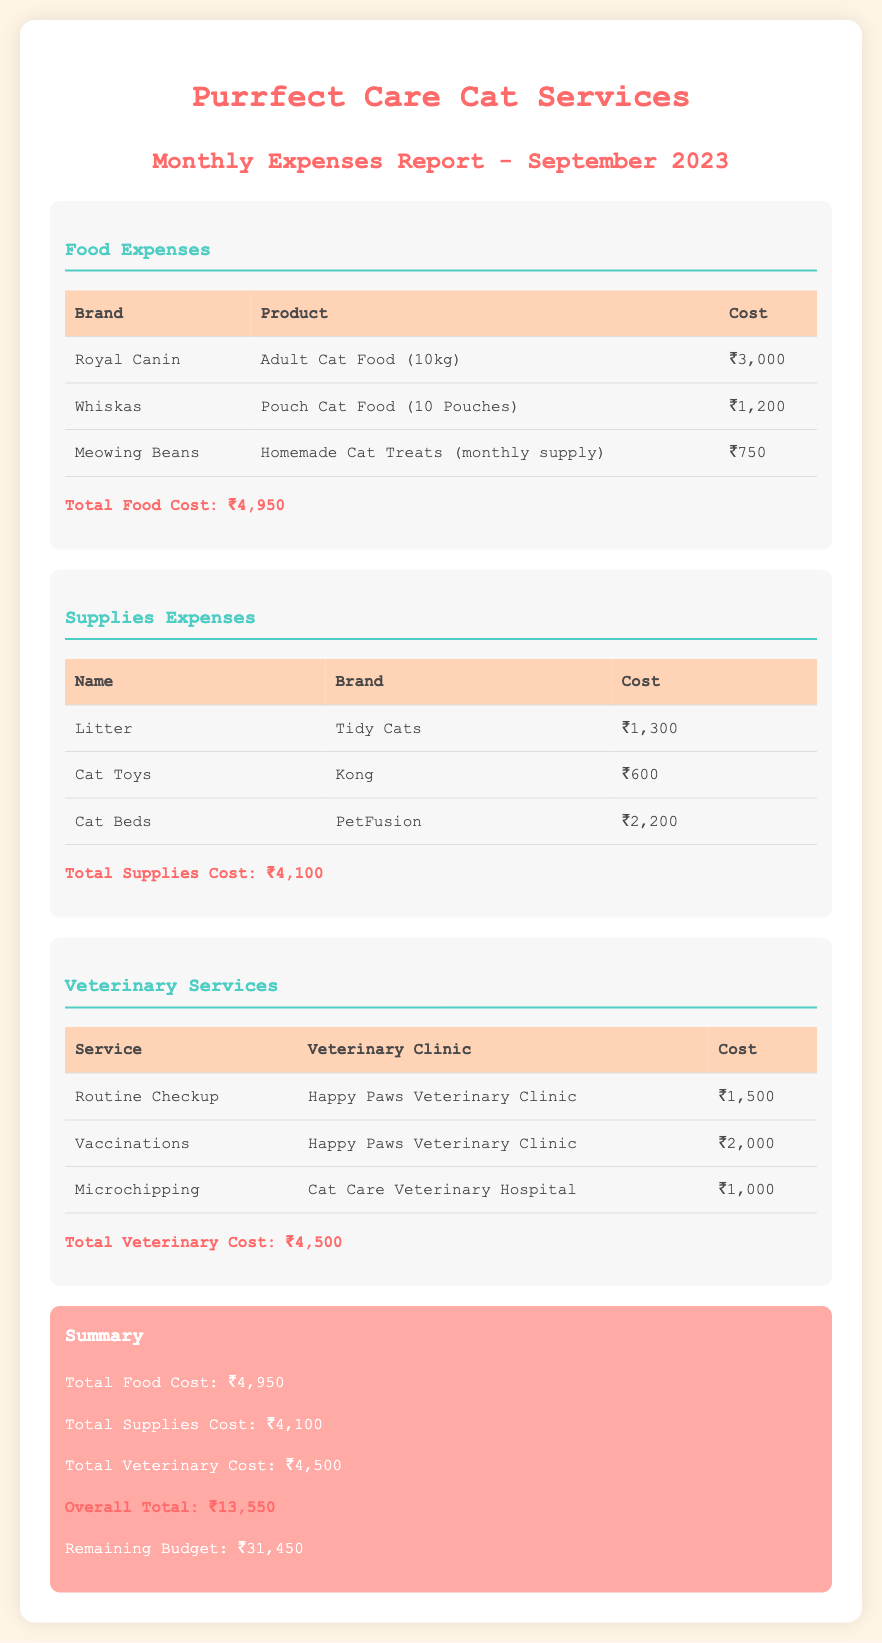What is the total food cost? The total food cost is listed at the end of the food expenses section, which sums up all the individual food costs.
Answer: ₹4,950 Which veterinary service costs the most? By comparing the costs of the listed veterinary services, the service with the highest cost can be identified.
Answer: Vaccinations What is the total supplies cost? The total supplies cost is provided at the conclusion of the supplies expenses section, summing all individual supply costs.
Answer: ₹4,100 How much is left in the budget? The remaining budget is clearly stated at the end of the summary section after the overall total expenses are calculated.
Answer: ₹31,450 How many pouches are included in the Whiskas product? The number of pouches is mentioned in the food expenses section under the Whiskas product.
Answer: 10 Pouches What is the cost of the Adult Cat Food from Royal Canin? The cost of this product is explicitly detailed in the food expenses table.
Answer: ₹3,000 What is the name of the veterinary clinic for microchipping? The name of the clinic is provided alongside the service details in the veterinary services section.
Answer: Cat Care Veterinary Hospital What type of litter is listed under supplies? The specific type of litter is enumerated in the supplies expenses section.
Answer: Tidy Cats What is the total veterinary cost? The total veterinary cost is summarized at the end of the veterinary services section, combining all the service costs listed.
Answer: ₹4,500 